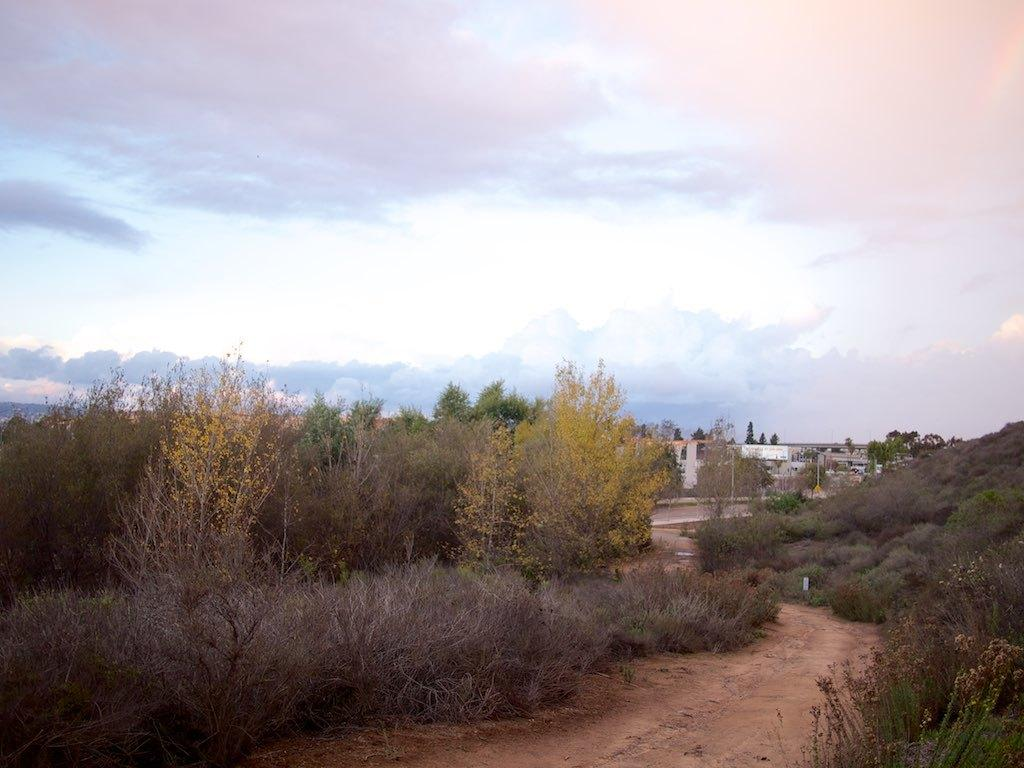What type of vegetation is present in the image? There are trees in the image. What color are the trees? The trees are green. What can be seen in the background of the image? There are buildings in the background of the image. What colors are visible in the sky in the image? The sky is blue and white. Can you see any food hanging from the trees in the image? There is no food hanging from the trees in the image; it only features green trees and buildings in the background. 